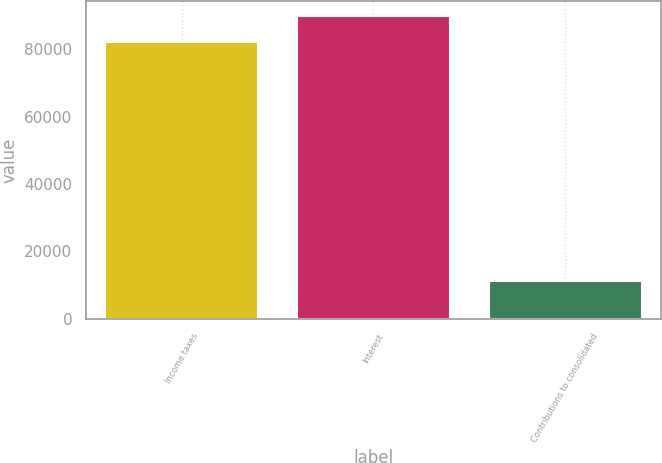Convert chart to OTSL. <chart><loc_0><loc_0><loc_500><loc_500><bar_chart><fcel>Income taxes<fcel>Interest<fcel>Contributions to consolidated<nl><fcel>82275<fcel>89745.9<fcel>11326<nl></chart> 